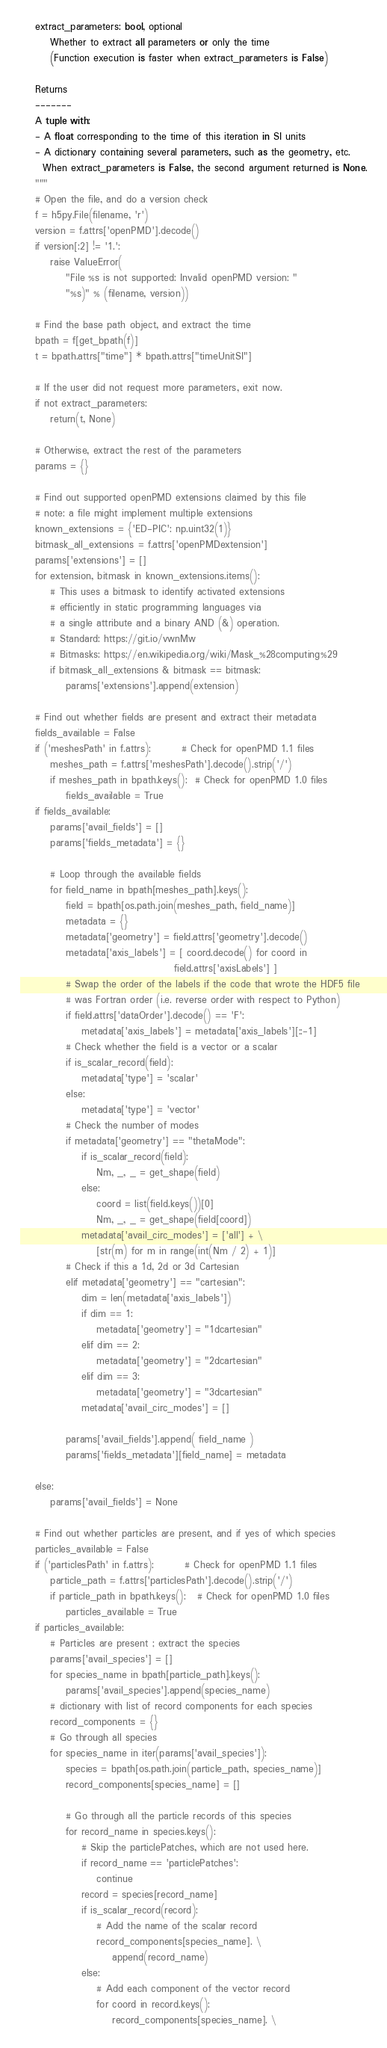<code> <loc_0><loc_0><loc_500><loc_500><_Python_>    extract_parameters: bool, optional
        Whether to extract all parameters or only the time
        (Function execution is faster when extract_parameters is False)

    Returns
    -------
    A tuple with:
    - A float corresponding to the time of this iteration in SI units
    - A dictionary containing several parameters, such as the geometry, etc.
      When extract_parameters is False, the second argument returned is None.
    """
    # Open the file, and do a version check
    f = h5py.File(filename, 'r')
    version = f.attrs['openPMD'].decode()
    if version[:2] != '1.':
        raise ValueError(
            "File %s is not supported: Invalid openPMD version: "
            "%s)" % (filename, version))

    # Find the base path object, and extract the time
    bpath = f[get_bpath(f)]
    t = bpath.attrs["time"] * bpath.attrs["timeUnitSI"]

    # If the user did not request more parameters, exit now.
    if not extract_parameters:
        return(t, None)

    # Otherwise, extract the rest of the parameters
    params = {}

    # Find out supported openPMD extensions claimed by this file
    # note: a file might implement multiple extensions
    known_extensions = {'ED-PIC': np.uint32(1)}
    bitmask_all_extensions = f.attrs['openPMDextension']
    params['extensions'] = []
    for extension, bitmask in known_extensions.items():
        # This uses a bitmask to identify activated extensions
        # efficiently in static programming languages via
        # a single attribute and a binary AND (&) operation.
        # Standard: https://git.io/vwnMw
        # Bitmasks: https://en.wikipedia.org/wiki/Mask_%28computing%29
        if bitmask_all_extensions & bitmask == bitmask:
            params['extensions'].append(extension)

    # Find out whether fields are present and extract their metadata
    fields_available = False
    if ('meshesPath' in f.attrs):        # Check for openPMD 1.1 files
        meshes_path = f.attrs['meshesPath'].decode().strip('/')
        if meshes_path in bpath.keys():  # Check for openPMD 1.0 files
            fields_available = True
    if fields_available:
        params['avail_fields'] = []
        params['fields_metadata'] = {}

        # Loop through the available fields
        for field_name in bpath[meshes_path].keys():
            field = bpath[os.path.join(meshes_path, field_name)]
            metadata = {}
            metadata['geometry'] = field.attrs['geometry'].decode()
            metadata['axis_labels'] = [ coord.decode() for coord in
                                        field.attrs['axisLabels'] ]
            # Swap the order of the labels if the code that wrote the HDF5 file
            # was Fortran order (i.e. reverse order with respect to Python)
            if field.attrs['dataOrder'].decode() == 'F':
                metadata['axis_labels'] = metadata['axis_labels'][::-1]
            # Check whether the field is a vector or a scalar
            if is_scalar_record(field):
                metadata['type'] = 'scalar'
            else:
                metadata['type'] = 'vector'
            # Check the number of modes
            if metadata['geometry'] == "thetaMode":
                if is_scalar_record(field):
                    Nm, _, _ = get_shape(field)
                else:
                    coord = list(field.keys())[0]
                    Nm, _, _ = get_shape(field[coord])
                metadata['avail_circ_modes'] = ['all'] + \
                    [str(m) for m in range(int(Nm / 2) + 1)]
            # Check if this a 1d, 2d or 3d Cartesian
            elif metadata['geometry'] == "cartesian":
                dim = len(metadata['axis_labels'])
                if dim == 1:
                    metadata['geometry'] = "1dcartesian"
                elif dim == 2:
                    metadata['geometry'] = "2dcartesian"
                elif dim == 3:
                    metadata['geometry'] = "3dcartesian"
                metadata['avail_circ_modes'] = []

            params['avail_fields'].append( field_name )
            params['fields_metadata'][field_name] = metadata

    else:
        params['avail_fields'] = None

    # Find out whether particles are present, and if yes of which species
    particles_available = False
    if ('particlesPath' in f.attrs):        # Check for openPMD 1.1 files
        particle_path = f.attrs['particlesPath'].decode().strip('/')
        if particle_path in bpath.keys():   # Check for openPMD 1.0 files
            particles_available = True
    if particles_available:
        # Particles are present ; extract the species
        params['avail_species'] = []
        for species_name in bpath[particle_path].keys():
            params['avail_species'].append(species_name)
        # dictionary with list of record components for each species
        record_components = {}
        # Go through all species
        for species_name in iter(params['avail_species']):
            species = bpath[os.path.join(particle_path, species_name)]
            record_components[species_name] = []

            # Go through all the particle records of this species
            for record_name in species.keys():
                # Skip the particlePatches, which are not used here.
                if record_name == 'particlePatches':
                    continue
                record = species[record_name]
                if is_scalar_record(record):
                    # Add the name of the scalar record
                    record_components[species_name]. \
                        append(record_name)
                else:
                    # Add each component of the vector record
                    for coord in record.keys():
                        record_components[species_name]. \</code> 